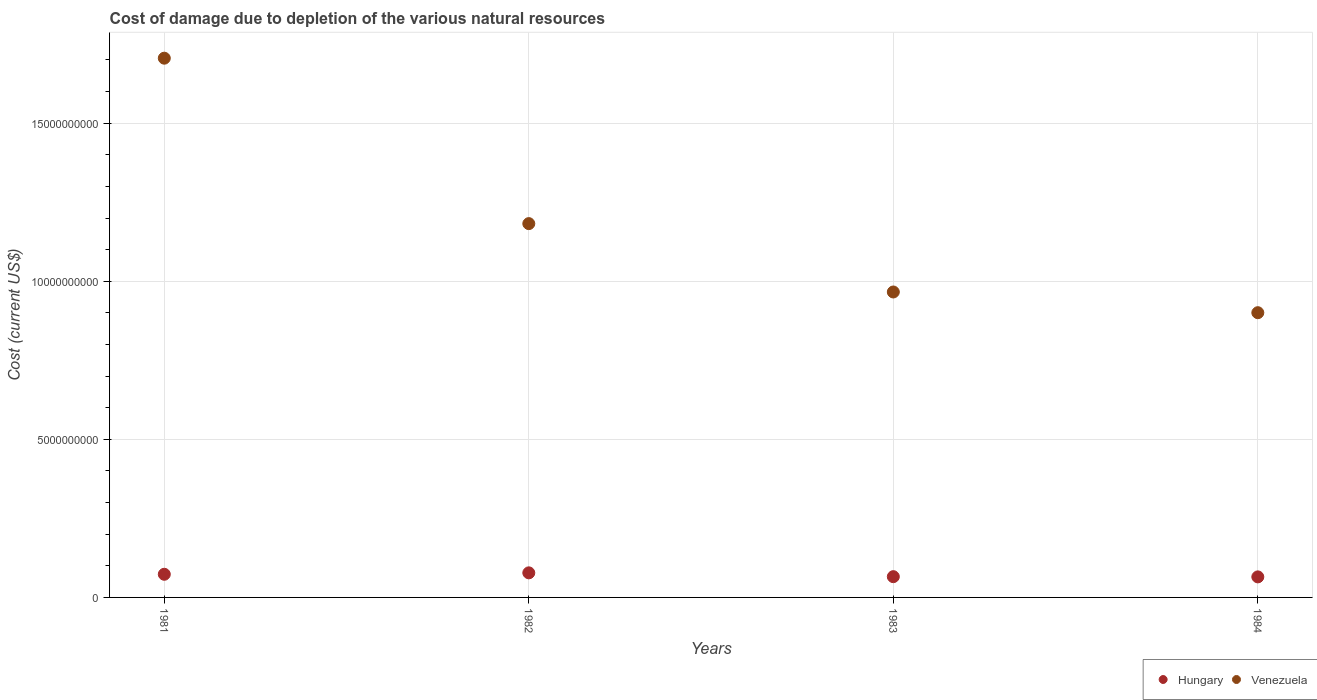How many different coloured dotlines are there?
Make the answer very short. 2. Is the number of dotlines equal to the number of legend labels?
Provide a short and direct response. Yes. What is the cost of damage caused due to the depletion of various natural resources in Venezuela in 1982?
Your answer should be very brief. 1.18e+1. Across all years, what is the maximum cost of damage caused due to the depletion of various natural resources in Hungary?
Provide a short and direct response. 7.78e+08. Across all years, what is the minimum cost of damage caused due to the depletion of various natural resources in Hungary?
Offer a terse response. 6.50e+08. What is the total cost of damage caused due to the depletion of various natural resources in Venezuela in the graph?
Ensure brevity in your answer.  4.75e+1. What is the difference between the cost of damage caused due to the depletion of various natural resources in Hungary in 1981 and that in 1982?
Provide a short and direct response. -4.52e+07. What is the difference between the cost of damage caused due to the depletion of various natural resources in Hungary in 1983 and the cost of damage caused due to the depletion of various natural resources in Venezuela in 1981?
Keep it short and to the point. -1.64e+1. What is the average cost of damage caused due to the depletion of various natural resources in Hungary per year?
Provide a succinct answer. 7.04e+08. In the year 1981, what is the difference between the cost of damage caused due to the depletion of various natural resources in Hungary and cost of damage caused due to the depletion of various natural resources in Venezuela?
Give a very brief answer. -1.63e+1. What is the ratio of the cost of damage caused due to the depletion of various natural resources in Venezuela in 1981 to that in 1983?
Provide a succinct answer. 1.77. What is the difference between the highest and the second highest cost of damage caused due to the depletion of various natural resources in Hungary?
Ensure brevity in your answer.  4.52e+07. What is the difference between the highest and the lowest cost of damage caused due to the depletion of various natural resources in Venezuela?
Offer a very short reply. 8.05e+09. In how many years, is the cost of damage caused due to the depletion of various natural resources in Hungary greater than the average cost of damage caused due to the depletion of various natural resources in Hungary taken over all years?
Offer a terse response. 2. How many dotlines are there?
Offer a very short reply. 2. Are the values on the major ticks of Y-axis written in scientific E-notation?
Provide a succinct answer. No. Does the graph contain any zero values?
Your answer should be very brief. No. Does the graph contain grids?
Your answer should be very brief. Yes. Where does the legend appear in the graph?
Your response must be concise. Bottom right. How are the legend labels stacked?
Your answer should be very brief. Horizontal. What is the title of the graph?
Provide a short and direct response. Cost of damage due to depletion of the various natural resources. Does "Ecuador" appear as one of the legend labels in the graph?
Ensure brevity in your answer.  No. What is the label or title of the Y-axis?
Provide a short and direct response. Cost (current US$). What is the Cost (current US$) of Hungary in 1981?
Your answer should be compact. 7.32e+08. What is the Cost (current US$) of Venezuela in 1981?
Offer a very short reply. 1.71e+1. What is the Cost (current US$) of Hungary in 1982?
Make the answer very short. 7.78e+08. What is the Cost (current US$) of Venezuela in 1982?
Give a very brief answer. 1.18e+1. What is the Cost (current US$) in Hungary in 1983?
Your answer should be very brief. 6.57e+08. What is the Cost (current US$) in Venezuela in 1983?
Provide a succinct answer. 9.66e+09. What is the Cost (current US$) in Hungary in 1984?
Offer a terse response. 6.50e+08. What is the Cost (current US$) of Venezuela in 1984?
Offer a terse response. 9.01e+09. Across all years, what is the maximum Cost (current US$) in Hungary?
Offer a very short reply. 7.78e+08. Across all years, what is the maximum Cost (current US$) of Venezuela?
Provide a succinct answer. 1.71e+1. Across all years, what is the minimum Cost (current US$) in Hungary?
Provide a succinct answer. 6.50e+08. Across all years, what is the minimum Cost (current US$) of Venezuela?
Offer a very short reply. 9.01e+09. What is the total Cost (current US$) in Hungary in the graph?
Provide a short and direct response. 2.82e+09. What is the total Cost (current US$) of Venezuela in the graph?
Make the answer very short. 4.75e+1. What is the difference between the Cost (current US$) of Hungary in 1981 and that in 1982?
Ensure brevity in your answer.  -4.52e+07. What is the difference between the Cost (current US$) of Venezuela in 1981 and that in 1982?
Your answer should be compact. 5.23e+09. What is the difference between the Cost (current US$) of Hungary in 1981 and that in 1983?
Provide a short and direct response. 7.57e+07. What is the difference between the Cost (current US$) of Venezuela in 1981 and that in 1983?
Ensure brevity in your answer.  7.40e+09. What is the difference between the Cost (current US$) of Hungary in 1981 and that in 1984?
Offer a terse response. 8.27e+07. What is the difference between the Cost (current US$) of Venezuela in 1981 and that in 1984?
Provide a succinct answer. 8.05e+09. What is the difference between the Cost (current US$) in Hungary in 1982 and that in 1983?
Ensure brevity in your answer.  1.21e+08. What is the difference between the Cost (current US$) in Venezuela in 1982 and that in 1983?
Provide a succinct answer. 2.16e+09. What is the difference between the Cost (current US$) of Hungary in 1982 and that in 1984?
Make the answer very short. 1.28e+08. What is the difference between the Cost (current US$) in Venezuela in 1982 and that in 1984?
Your response must be concise. 2.82e+09. What is the difference between the Cost (current US$) in Hungary in 1983 and that in 1984?
Provide a succinct answer. 7.03e+06. What is the difference between the Cost (current US$) in Venezuela in 1983 and that in 1984?
Your response must be concise. 6.55e+08. What is the difference between the Cost (current US$) of Hungary in 1981 and the Cost (current US$) of Venezuela in 1982?
Offer a terse response. -1.11e+1. What is the difference between the Cost (current US$) of Hungary in 1981 and the Cost (current US$) of Venezuela in 1983?
Make the answer very short. -8.93e+09. What is the difference between the Cost (current US$) of Hungary in 1981 and the Cost (current US$) of Venezuela in 1984?
Your response must be concise. -8.27e+09. What is the difference between the Cost (current US$) in Hungary in 1982 and the Cost (current US$) in Venezuela in 1983?
Ensure brevity in your answer.  -8.88e+09. What is the difference between the Cost (current US$) in Hungary in 1982 and the Cost (current US$) in Venezuela in 1984?
Keep it short and to the point. -8.23e+09. What is the difference between the Cost (current US$) of Hungary in 1983 and the Cost (current US$) of Venezuela in 1984?
Give a very brief answer. -8.35e+09. What is the average Cost (current US$) of Hungary per year?
Provide a succinct answer. 7.04e+08. What is the average Cost (current US$) of Venezuela per year?
Provide a short and direct response. 1.19e+1. In the year 1981, what is the difference between the Cost (current US$) of Hungary and Cost (current US$) of Venezuela?
Your response must be concise. -1.63e+1. In the year 1982, what is the difference between the Cost (current US$) in Hungary and Cost (current US$) in Venezuela?
Your answer should be very brief. -1.10e+1. In the year 1983, what is the difference between the Cost (current US$) of Hungary and Cost (current US$) of Venezuela?
Your answer should be very brief. -9.00e+09. In the year 1984, what is the difference between the Cost (current US$) in Hungary and Cost (current US$) in Venezuela?
Offer a very short reply. -8.36e+09. What is the ratio of the Cost (current US$) of Hungary in 1981 to that in 1982?
Provide a succinct answer. 0.94. What is the ratio of the Cost (current US$) in Venezuela in 1981 to that in 1982?
Offer a very short reply. 1.44. What is the ratio of the Cost (current US$) in Hungary in 1981 to that in 1983?
Make the answer very short. 1.12. What is the ratio of the Cost (current US$) of Venezuela in 1981 to that in 1983?
Provide a succinct answer. 1.77. What is the ratio of the Cost (current US$) of Hungary in 1981 to that in 1984?
Offer a very short reply. 1.13. What is the ratio of the Cost (current US$) in Venezuela in 1981 to that in 1984?
Provide a short and direct response. 1.89. What is the ratio of the Cost (current US$) of Hungary in 1982 to that in 1983?
Keep it short and to the point. 1.18. What is the ratio of the Cost (current US$) of Venezuela in 1982 to that in 1983?
Offer a very short reply. 1.22. What is the ratio of the Cost (current US$) of Hungary in 1982 to that in 1984?
Your answer should be compact. 1.2. What is the ratio of the Cost (current US$) in Venezuela in 1982 to that in 1984?
Your answer should be very brief. 1.31. What is the ratio of the Cost (current US$) of Hungary in 1983 to that in 1984?
Offer a terse response. 1.01. What is the ratio of the Cost (current US$) in Venezuela in 1983 to that in 1984?
Ensure brevity in your answer.  1.07. What is the difference between the highest and the second highest Cost (current US$) of Hungary?
Keep it short and to the point. 4.52e+07. What is the difference between the highest and the second highest Cost (current US$) of Venezuela?
Ensure brevity in your answer.  5.23e+09. What is the difference between the highest and the lowest Cost (current US$) of Hungary?
Give a very brief answer. 1.28e+08. What is the difference between the highest and the lowest Cost (current US$) in Venezuela?
Your answer should be compact. 8.05e+09. 